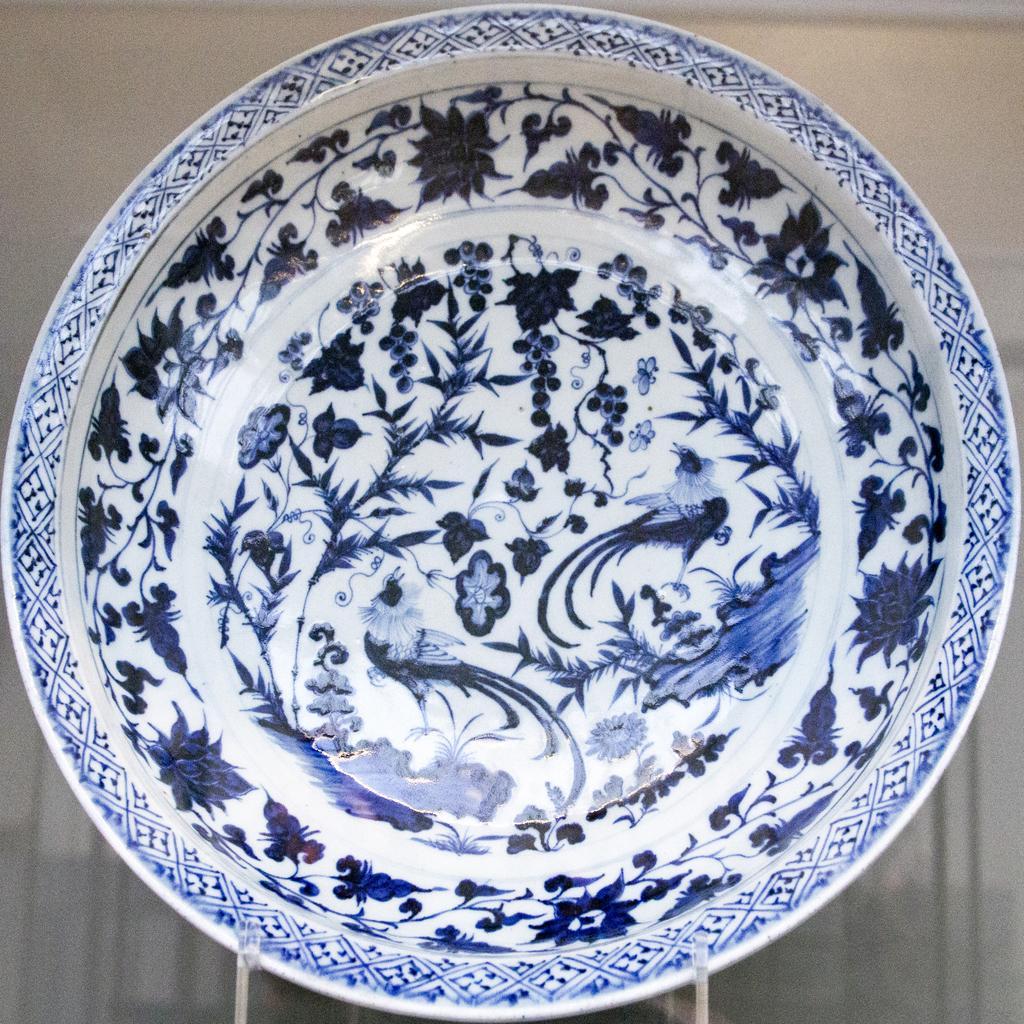How would you summarize this image in a sentence or two? In this picture there is a plate, on the table. The plate has floral designs. 